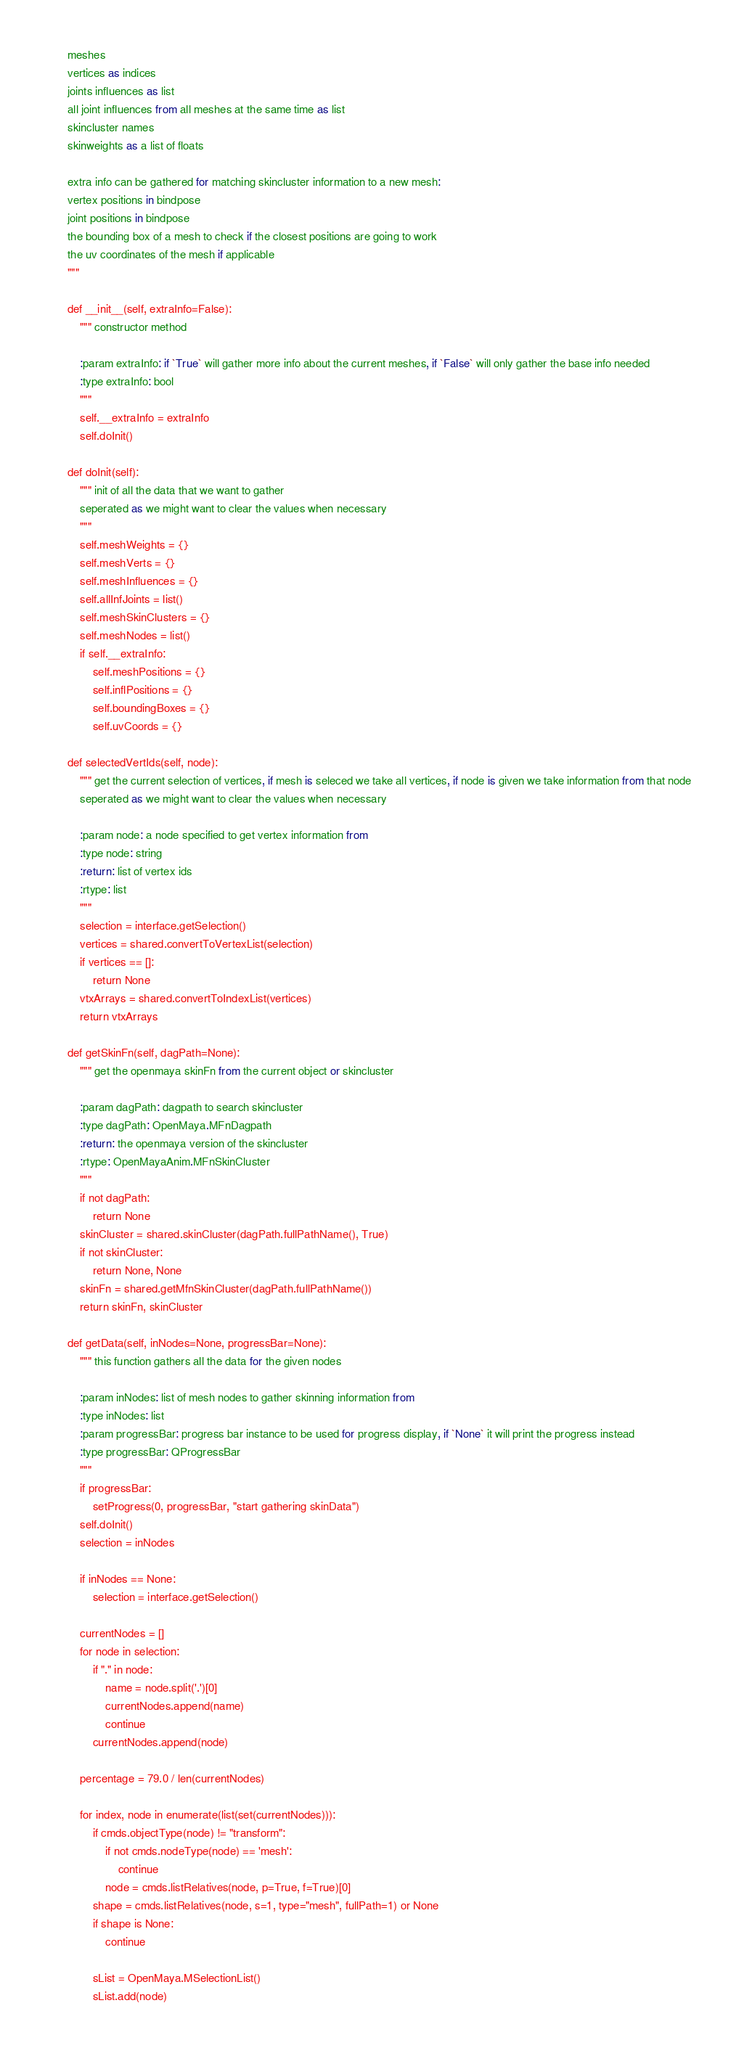Convert code to text. <code><loc_0><loc_0><loc_500><loc_500><_Python_>    meshes
    vertices as indices
    joints influences as list
    all joint influences from all meshes at the same time as list
    skincluster names
    skinweights as a list of floats

    extra info can be gathered for matching skincluster information to a new mesh:
    vertex positions in bindpose
    joint positions in bindpose
    the bounding box of a mesh to check if the closest positions are going to work
    the uv coordinates of the mesh if applicable
    """

    def __init__(self, extraInfo=False):
        """ constructor method

        :param extraInfo: if `True` will gather more info about the current meshes, if `False` will only gather the base info needed
        :type extraInfo: bool
        """
        self.__extraInfo = extraInfo
        self.doInit()

    def doInit(self):
        """ init of all the data that we want to gather
        seperated as we might want to clear the values when necessary
        """
        self.meshWeights = {}
        self.meshVerts = {}
        self.meshInfluences = {}
        self.allInfJoints = list()
        self.meshSkinClusters = {}
        self.meshNodes = list()
        if self.__extraInfo:
            self.meshPositions = {}
            self.inflPositions = {}
            self.boundingBoxes = {}
            self.uvCoords = {}

    def selectedVertIds(self, node):
        """ get the current selection of vertices, if mesh is seleced we take all vertices, if node is given we take information from that node
        seperated as we might want to clear the values when necessary

        :param node: a node specified to get vertex information from
        :type node: string
        :return: list of vertex ids
        :rtype: list
        """
        selection = interface.getSelection()
        vertices = shared.convertToVertexList(selection)
        if vertices == []:
            return None
        vtxArrays = shared.convertToIndexList(vertices)
        return vtxArrays

    def getSkinFn(self, dagPath=None):
        """ get the openmaya skinFn from the current object or skincluster

        :param dagPath: dagpath to search skincluster
        :type dagPath: OpenMaya.MFnDagpath
        :return: the openmaya version of the skincluster
        :rtype: OpenMayaAnim.MFnSkinCluster
        """
        if not dagPath:
            return None
        skinCluster = shared.skinCluster(dagPath.fullPathName(), True)
        if not skinCluster:
            return None, None
        skinFn = shared.getMfnSkinCluster(dagPath.fullPathName())
        return skinFn, skinCluster

    def getData(self, inNodes=None, progressBar=None):
        """ this function gathers all the data for the given nodes

        :param inNodes: list of mesh nodes to gather skinning information from
        :type inNodes: list
        :param progressBar: progress bar instance to be used for progress display, if `None` it will print the progress instead
        :type progressBar: QProgressBar
        """
        if progressBar:
            setProgress(0, progressBar, "start gathering skinData")
        self.doInit()
        selection = inNodes

        if inNodes == None:
            selection = interface.getSelection()

        currentNodes = []
        for node in selection:
            if "." in node:
                name = node.split('.')[0]
                currentNodes.append(name)
                continue
            currentNodes.append(node)

        percentage = 79.0 / len(currentNodes)

        for index, node in enumerate(list(set(currentNodes))):
            if cmds.objectType(node) != "transform":
                if not cmds.nodeType(node) == 'mesh':
                    continue
                node = cmds.listRelatives(node, p=True, f=True)[0]
            shape = cmds.listRelatives(node, s=1, type="mesh", fullPath=1) or None
            if shape is None:
                continue

            sList = OpenMaya.MSelectionList()
            sList.add(node)</code> 